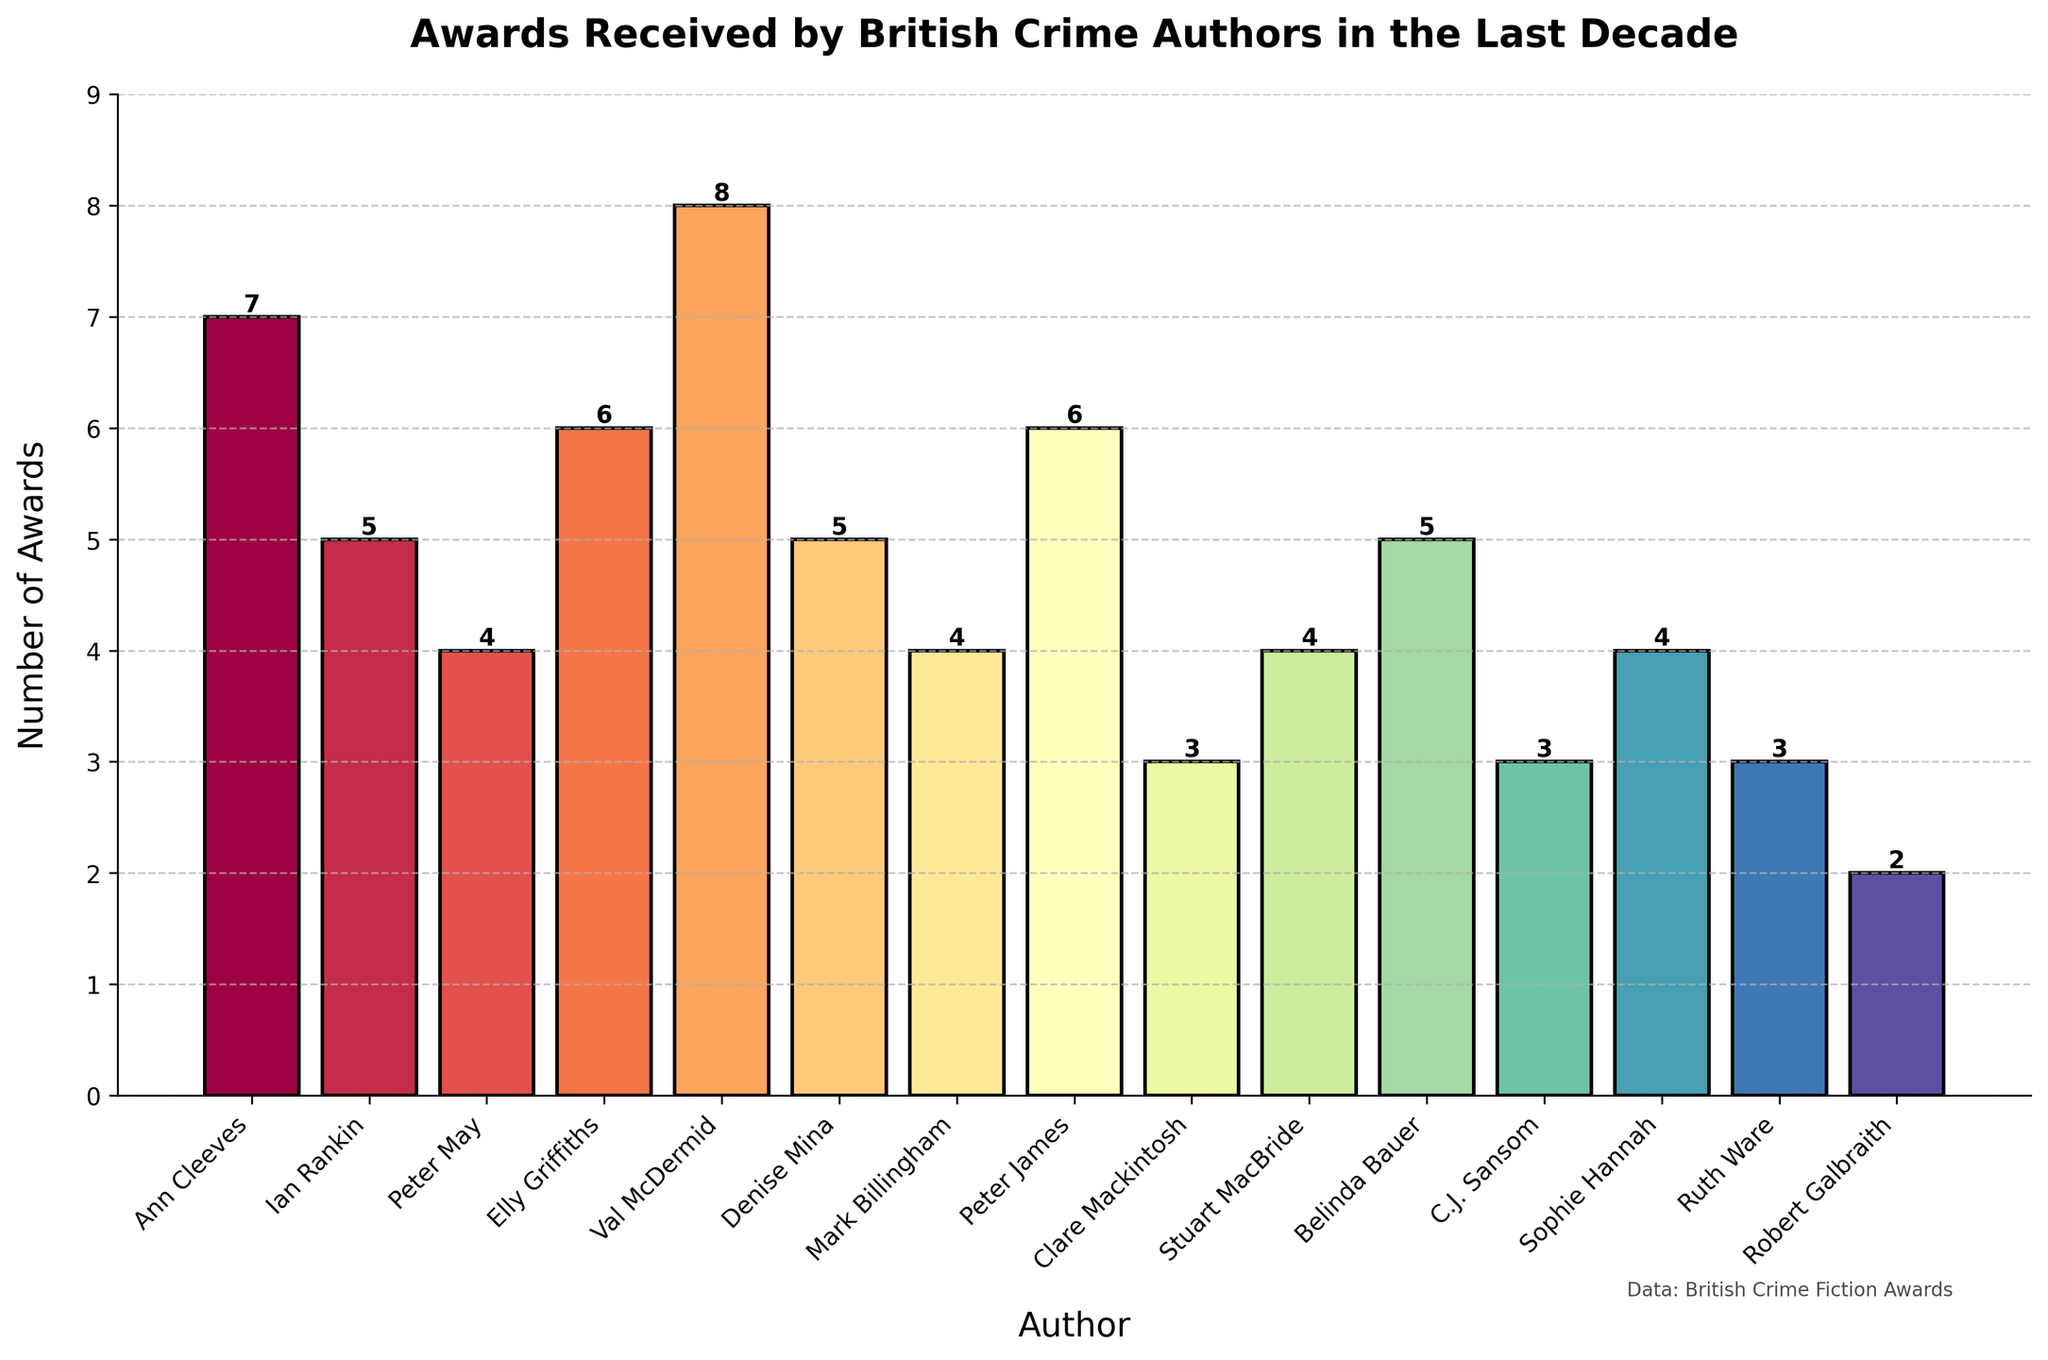What's the average number of awards won by these British crime authors? To find the average, sum up all the awards and then divide by the number of authors. The total number of awards is (7 + 5 + 4 + 6 + 8 + 5 + 4 + 6 + 3 + 4 + 5 + 3 + 4 + 3 + 2) = 69. There are 15 authors. So, the average number of awards is 69 / 15 = 4.6
Answer: 4.6 Which author has won the most awards? Look at the tallest bar in the plot to identify the author with the highest number of awards. The tallest bar corresponds to Val McDermid with 8 awards.
Answer: Val McDermid Which author has won the least number of awards? Look at the shortest bar in the plot to identify the author with the lowest number of awards. The shortest bar corresponds to Robert Galbraith with 2 awards.
Answer: Robert Galbraith What is the total combined number of awards won by Ann Cleeves and Elly Griffiths? To find the total number, add the number of awards won by both authors. Ann Cleeves has 7 awards, and Elly Griffiths has 6 awards. So, 7 + 6 = 13
Answer: 13 How many more awards does Val McDermid have compared to Robert Galbraith? Subtract the number of awards won by Robert Galbraith from the number of awards won by Val McDermid. Val McDermid has 8 awards, and Robert Galbraith has 2 awards. So, 8 - 2 = 6
Answer: 6 Which two authors have the same number of awards and what is that number? Look for bars of equal height to identify authors with the same number of awards. Peter May, Mark Billingham, Stuart MacBride, and Sophie Hannah each have 4 awards.
Answer: Peter May, Mark Billingham, Stuart MacBride, Sophie Hannah: 4 What is the combined number of awards won by all the authors who have received 5 awards? Sum the awards for all authors with 5 awards. Ian Rankin, Denise Mina, and Belinda Bauer each have 5 awards. So, 5 + 5 + 5 = 15
Answer: 15 What is the difference in the number of awards between the author with the most awards and the author with the second-most awards? Identify the top two authors by award count. Val McDermid has the most with 8 awards, followed by Ann Cleeves with 7 awards. So, the difference is 8 - 7 = 1
Answer: 1 How many authors have won exactly 3 awards? Count the bars corresponding to 3 awards. Clare Mackintosh, C.J. Sansom, and Ruth Ware each have 3 awards. So, there are 3 authors.
Answer: 3 